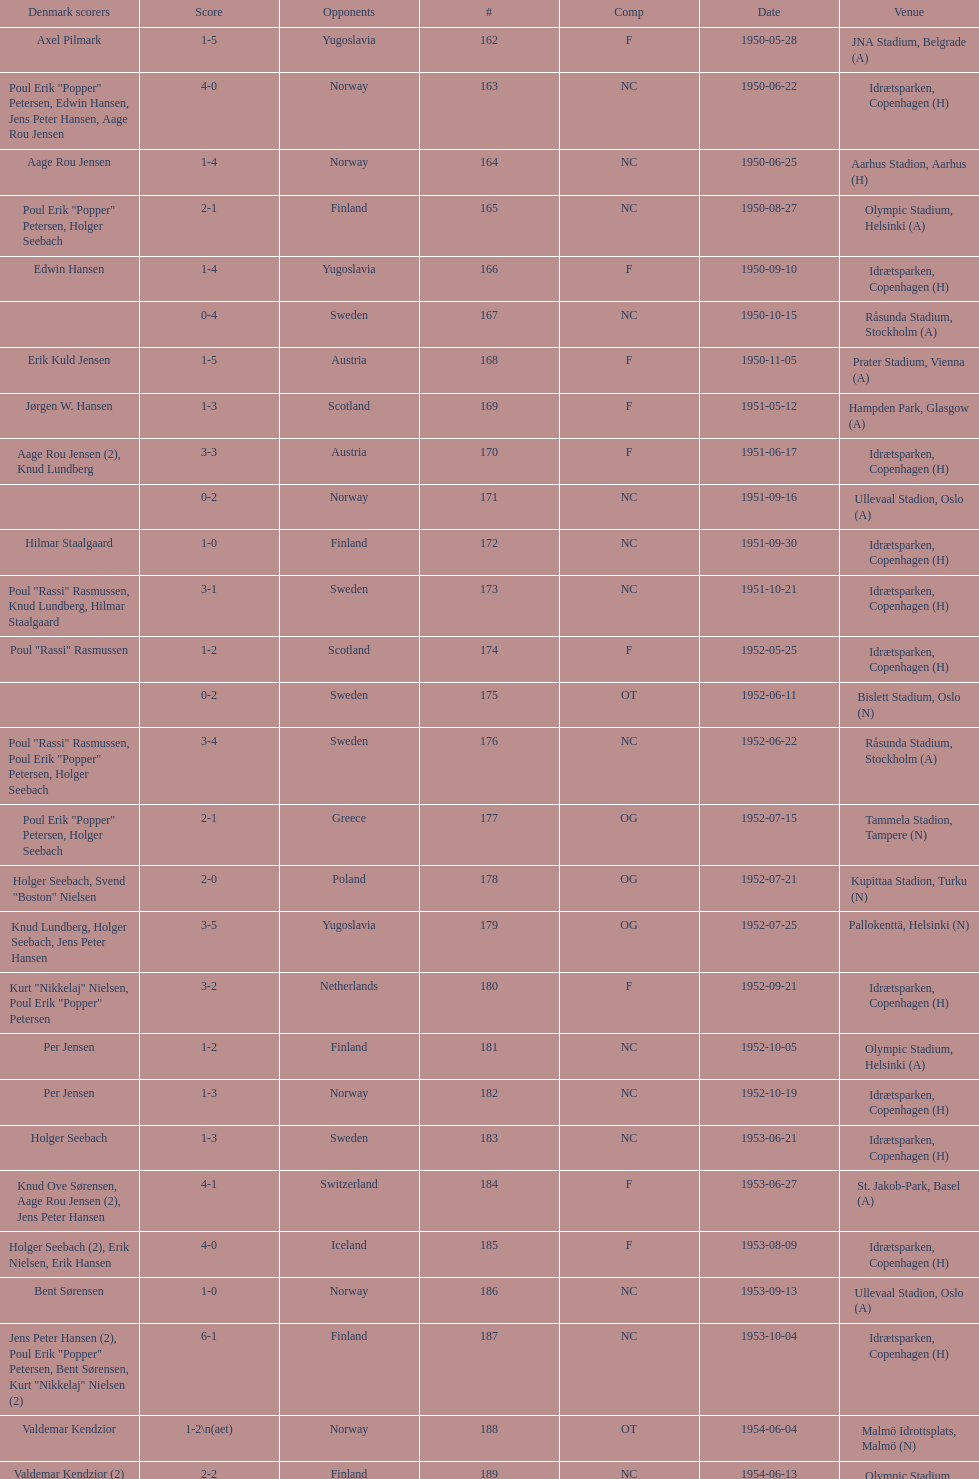What was the difference in score between the two teams in the last game? 1. 